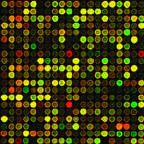what is genetic analysis of cancers being utilized to do?
Answer the question using a single word or phrase. To identify mutations that can be targeted by drugs 